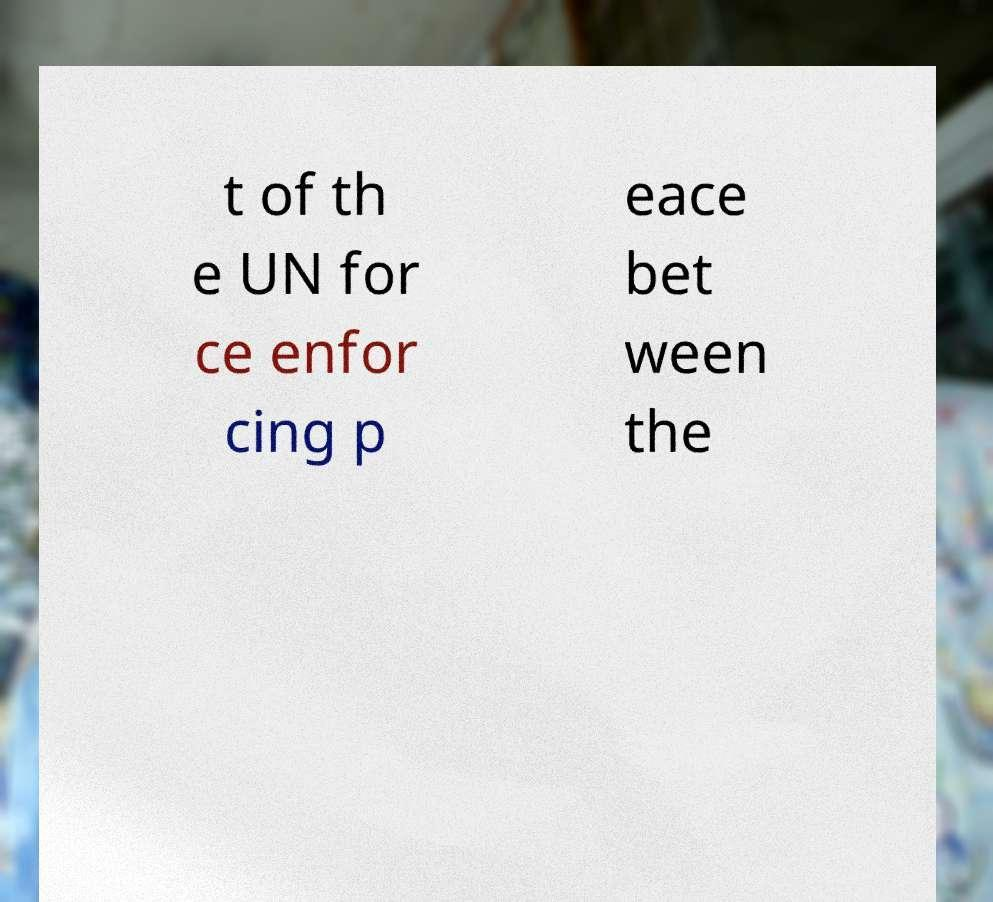Please read and relay the text visible in this image. What does it say? t of th e UN for ce enfor cing p eace bet ween the 